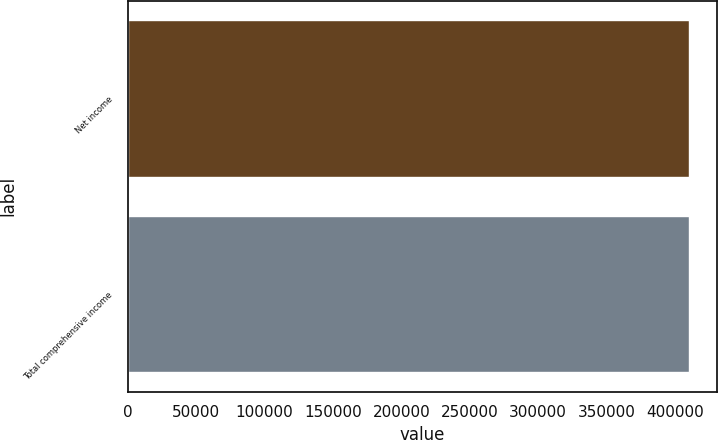Convert chart to OTSL. <chart><loc_0><loc_0><loc_500><loc_500><bar_chart><fcel>Net income<fcel>Total comprehensive income<nl><fcel>410395<fcel>410395<nl></chart> 